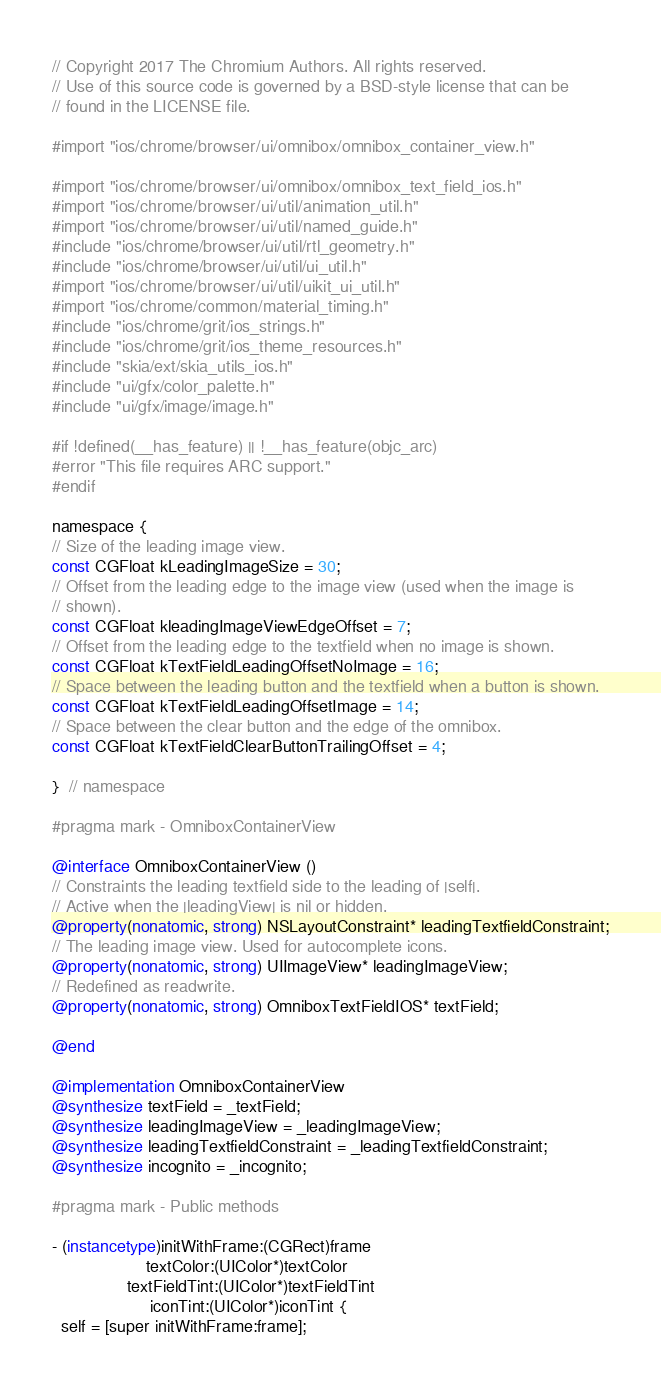Convert code to text. <code><loc_0><loc_0><loc_500><loc_500><_ObjectiveC_>// Copyright 2017 The Chromium Authors. All rights reserved.
// Use of this source code is governed by a BSD-style license that can be
// found in the LICENSE file.

#import "ios/chrome/browser/ui/omnibox/omnibox_container_view.h"

#import "ios/chrome/browser/ui/omnibox/omnibox_text_field_ios.h"
#import "ios/chrome/browser/ui/util/animation_util.h"
#import "ios/chrome/browser/ui/util/named_guide.h"
#include "ios/chrome/browser/ui/util/rtl_geometry.h"
#include "ios/chrome/browser/ui/util/ui_util.h"
#import "ios/chrome/browser/ui/util/uikit_ui_util.h"
#import "ios/chrome/common/material_timing.h"
#include "ios/chrome/grit/ios_strings.h"
#include "ios/chrome/grit/ios_theme_resources.h"
#include "skia/ext/skia_utils_ios.h"
#include "ui/gfx/color_palette.h"
#include "ui/gfx/image/image.h"

#if !defined(__has_feature) || !__has_feature(objc_arc)
#error "This file requires ARC support."
#endif

namespace {
// Size of the leading image view.
const CGFloat kLeadingImageSize = 30;
// Offset from the leading edge to the image view (used when the image is
// shown).
const CGFloat kleadingImageViewEdgeOffset = 7;
// Offset from the leading edge to the textfield when no image is shown.
const CGFloat kTextFieldLeadingOffsetNoImage = 16;
// Space between the leading button and the textfield when a button is shown.
const CGFloat kTextFieldLeadingOffsetImage = 14;
// Space between the clear button and the edge of the omnibox.
const CGFloat kTextFieldClearButtonTrailingOffset = 4;

}  // namespace

#pragma mark - OmniboxContainerView

@interface OmniboxContainerView ()
// Constraints the leading textfield side to the leading of |self|.
// Active when the |leadingView| is nil or hidden.
@property(nonatomic, strong) NSLayoutConstraint* leadingTextfieldConstraint;
// The leading image view. Used for autocomplete icons.
@property(nonatomic, strong) UIImageView* leadingImageView;
// Redefined as readwrite.
@property(nonatomic, strong) OmniboxTextFieldIOS* textField;

@end

@implementation OmniboxContainerView
@synthesize textField = _textField;
@synthesize leadingImageView = _leadingImageView;
@synthesize leadingTextfieldConstraint = _leadingTextfieldConstraint;
@synthesize incognito = _incognito;

#pragma mark - Public methods

- (instancetype)initWithFrame:(CGRect)frame
                    textColor:(UIColor*)textColor
                textFieldTint:(UIColor*)textFieldTint
                     iconTint:(UIColor*)iconTint {
  self = [super initWithFrame:frame];</code> 